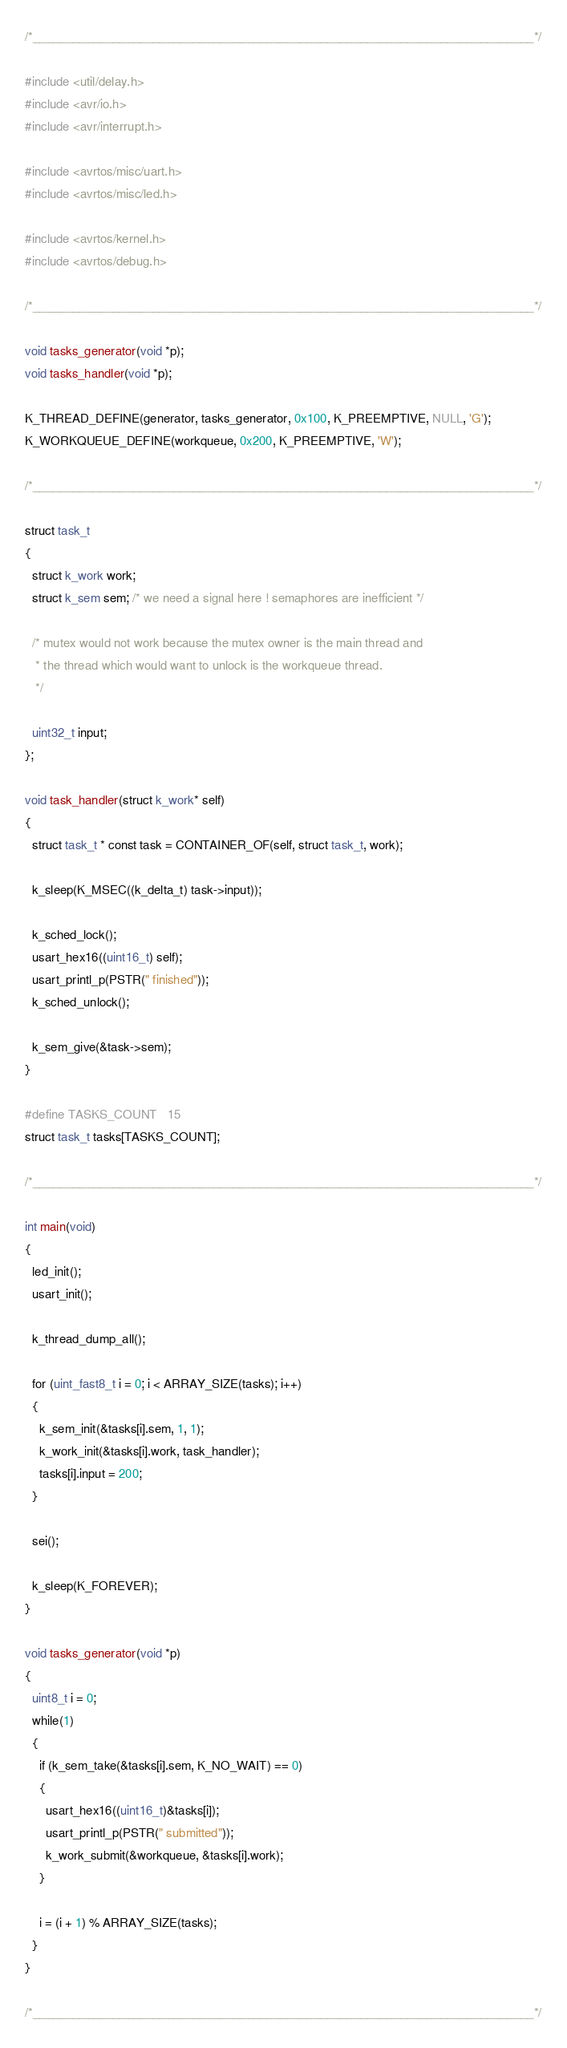Convert code to text. <code><loc_0><loc_0><loc_500><loc_500><_C_>/*___________________________________________________________________________*/

#include <util/delay.h>
#include <avr/io.h>
#include <avr/interrupt.h>

#include <avrtos/misc/uart.h>
#include <avrtos/misc/led.h>

#include <avrtos/kernel.h>
#include <avrtos/debug.h>

/*___________________________________________________________________________*/

void tasks_generator(void *p);
void tasks_handler(void *p);

K_THREAD_DEFINE(generator, tasks_generator, 0x100, K_PREEMPTIVE, NULL, 'G');
K_WORKQUEUE_DEFINE(workqueue, 0x200, K_PREEMPTIVE, 'W');

/*___________________________________________________________________________*/

struct task_t
{
  struct k_work work;
  struct k_sem sem; /* we need a signal here ! semaphores are inefficient */

  /* mutex would not work because the mutex owner is the main thread and 
   * the thread which would want to unlock is the workqueue thread.
   */

  uint32_t input;
};

void task_handler(struct k_work* self)
{
  struct task_t * const task = CONTAINER_OF(self, struct task_t, work);

  k_sleep(K_MSEC((k_delta_t) task->input));

  k_sched_lock();
  usart_hex16((uint16_t) self);
  usart_printl_p(PSTR(" finished"));
  k_sched_unlock();

  k_sem_give(&task->sem);
}

#define TASKS_COUNT   15
struct task_t tasks[TASKS_COUNT];

/*___________________________________________________________________________*/

int main(void)
{
  led_init();
  usart_init();
  
  k_thread_dump_all();

  for (uint_fast8_t i = 0; i < ARRAY_SIZE(tasks); i++)
  {
    k_sem_init(&tasks[i].sem, 1, 1);
    k_work_init(&tasks[i].work, task_handler);
    tasks[i].input = 200;
  }

  sei();

  k_sleep(K_FOREVER);
}

void tasks_generator(void *p)
{
  uint8_t i = 0;
  while(1)
  {
    if (k_sem_take(&tasks[i].sem, K_NO_WAIT) == 0)
    {
      usart_hex16((uint16_t)&tasks[i]);
      usart_printl_p(PSTR(" submitted"));
      k_work_submit(&workqueue, &tasks[i].work);
    }

    i = (i + 1) % ARRAY_SIZE(tasks);
  }
}

/*___________________________________________________________________________*/</code> 